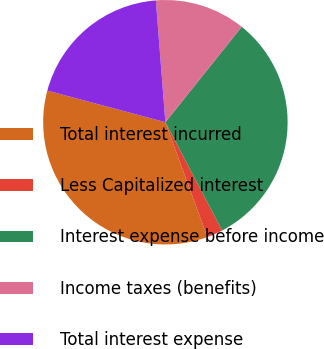Convert chart to OTSL. <chart><loc_0><loc_0><loc_500><loc_500><pie_chart><fcel>Total interest incurred<fcel>Less Capitalized interest<fcel>Interest expense before income<fcel>Income taxes (benefits)<fcel>Total interest expense<nl><fcel>34.74%<fcel>2.11%<fcel>31.58%<fcel>11.98%<fcel>19.59%<nl></chart> 